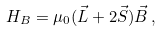<formula> <loc_0><loc_0><loc_500><loc_500>H _ { B } = \mu _ { 0 } ( \vec { L } + 2 \vec { S } ) \vec { B } \, ,</formula> 